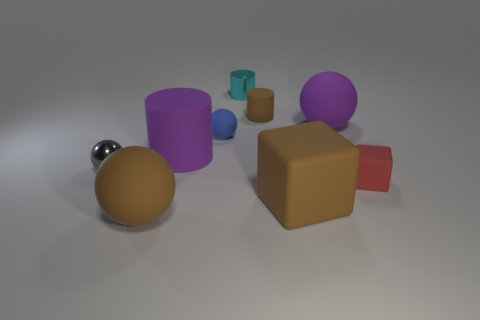Can you describe the textures visible on the objects? Each object appears to have a smooth finish; however, the metallic sphere and the small metal object reflect light, suggesting a polished, reflective texture.  Are there any patterns or designs on the objects? No, the objects do not have any intricate patterns or designs. They are all solid in color with a simple, minimalist aesthetic. 